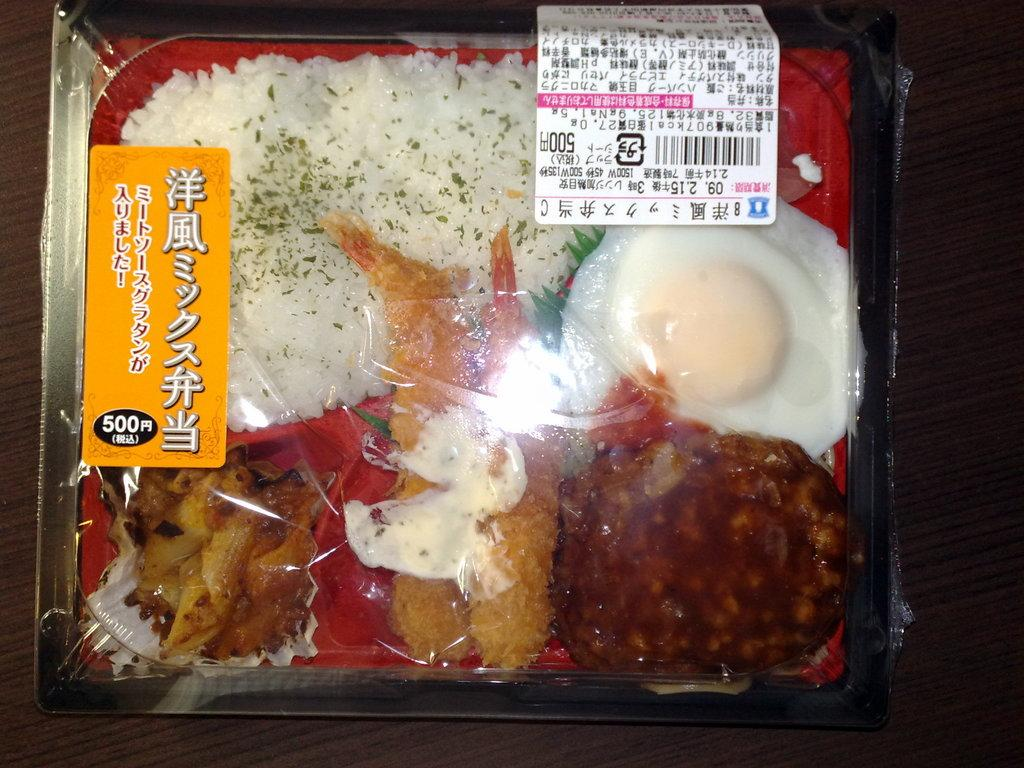What is the main object in the image? There is a bowl in the image. What is the bowl placed on? The bowl is on a wooden object. What is inside the bowl? There are food items in the bowl. How is the bowl covered? The bowl is covered with a plastic cover. What can be seen on the plastic cover? There are labels on the plastic cover. How many pigs are visible in the image? There are no pigs present in the image. What angle is the bowl placed at in the image? The angle at which the bowl is placed cannot be determined from the image. 